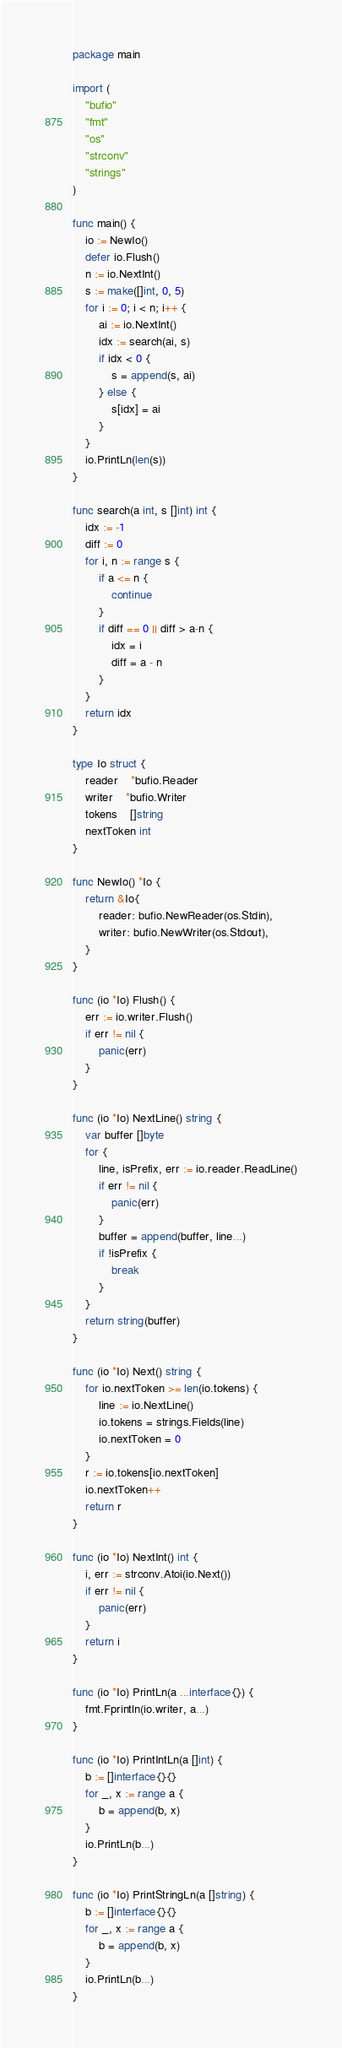<code> <loc_0><loc_0><loc_500><loc_500><_Go_>package main

import (
	"bufio"
	"fmt"
	"os"
	"strconv"
	"strings"
)

func main() {
	io := NewIo()
	defer io.Flush()
	n := io.NextInt()
	s := make([]int, 0, 5)
	for i := 0; i < n; i++ {
		ai := io.NextInt()
		idx := search(ai, s)
		if idx < 0 {
			s = append(s, ai)
		} else {
			s[idx] = ai
		}
	}
	io.PrintLn(len(s))
}

func search(a int, s []int) int {
	idx := -1
	diff := 0
	for i, n := range s {
		if a <= n {
			continue
		}
		if diff == 0 || diff > a-n {
			idx = i
			diff = a - n
		}
	}
	return idx
}

type Io struct {
	reader    *bufio.Reader
	writer    *bufio.Writer
	tokens    []string
	nextToken int
}

func NewIo() *Io {
	return &Io{
		reader: bufio.NewReader(os.Stdin),
		writer: bufio.NewWriter(os.Stdout),
	}
}

func (io *Io) Flush() {
	err := io.writer.Flush()
	if err != nil {
		panic(err)
	}
}

func (io *Io) NextLine() string {
	var buffer []byte
	for {
		line, isPrefix, err := io.reader.ReadLine()
		if err != nil {
			panic(err)
		}
		buffer = append(buffer, line...)
		if !isPrefix {
			break
		}
	}
	return string(buffer)
}

func (io *Io) Next() string {
	for io.nextToken >= len(io.tokens) {
		line := io.NextLine()
		io.tokens = strings.Fields(line)
		io.nextToken = 0
	}
	r := io.tokens[io.nextToken]
	io.nextToken++
	return r
}

func (io *Io) NextInt() int {
	i, err := strconv.Atoi(io.Next())
	if err != nil {
		panic(err)
	}
	return i
}

func (io *Io) PrintLn(a ...interface{}) {
	fmt.Fprintln(io.writer, a...)
}

func (io *Io) PrintIntLn(a []int) {
	b := []interface{}{}
	for _, x := range a {
		b = append(b, x)
	}
	io.PrintLn(b...)
}

func (io *Io) PrintStringLn(a []string) {
	b := []interface{}{}
	for _, x := range a {
		b = append(b, x)
	}
	io.PrintLn(b...)
}
</code> 